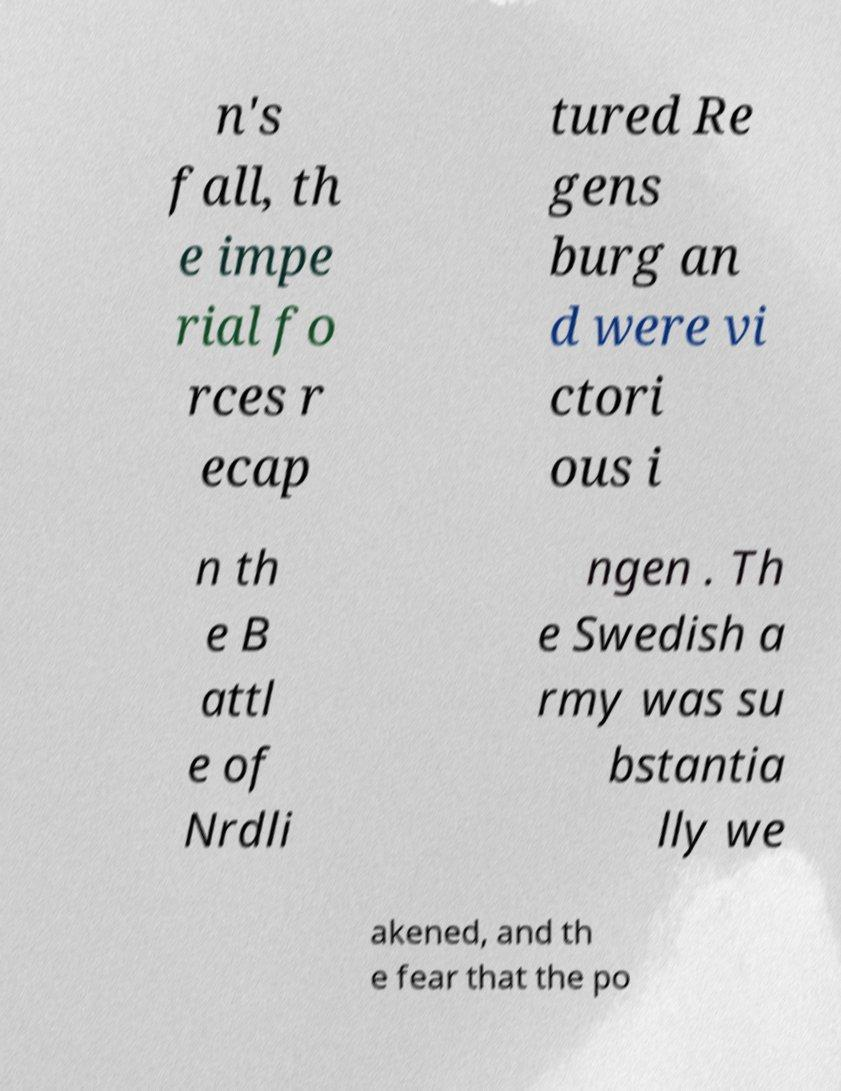Could you assist in decoding the text presented in this image and type it out clearly? n's fall, th e impe rial fo rces r ecap tured Re gens burg an d were vi ctori ous i n th e B attl e of Nrdli ngen . Th e Swedish a rmy was su bstantia lly we akened, and th e fear that the po 